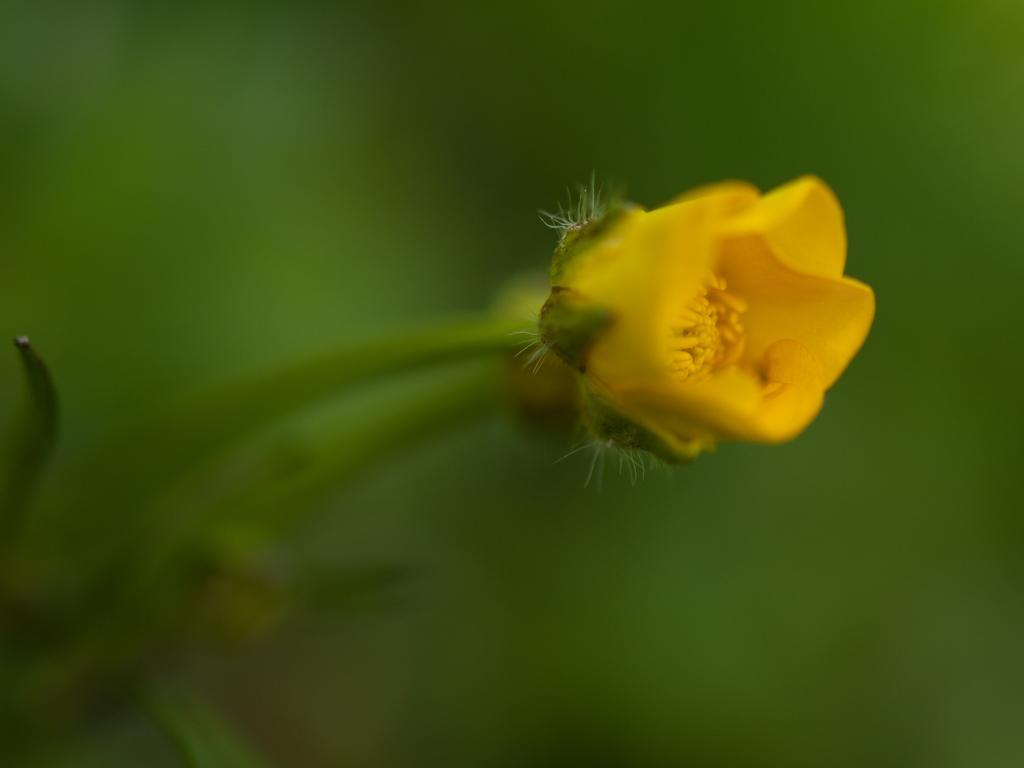In one or two sentences, can you explain what this image depicts? In this picture I can see yellow color flower to the plant and I can see blurry background. 